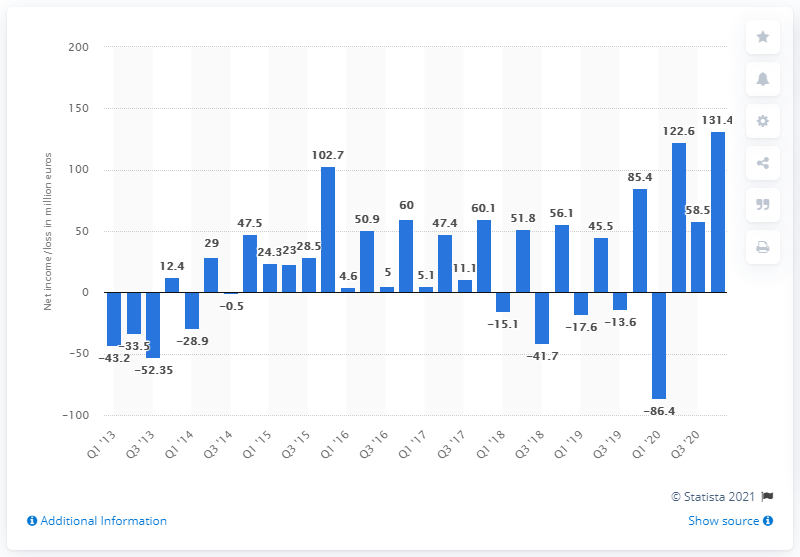Mention a couple of crucial points in this snapshot. In the most recent quarter, Zalando's net income was 131.4 million. 